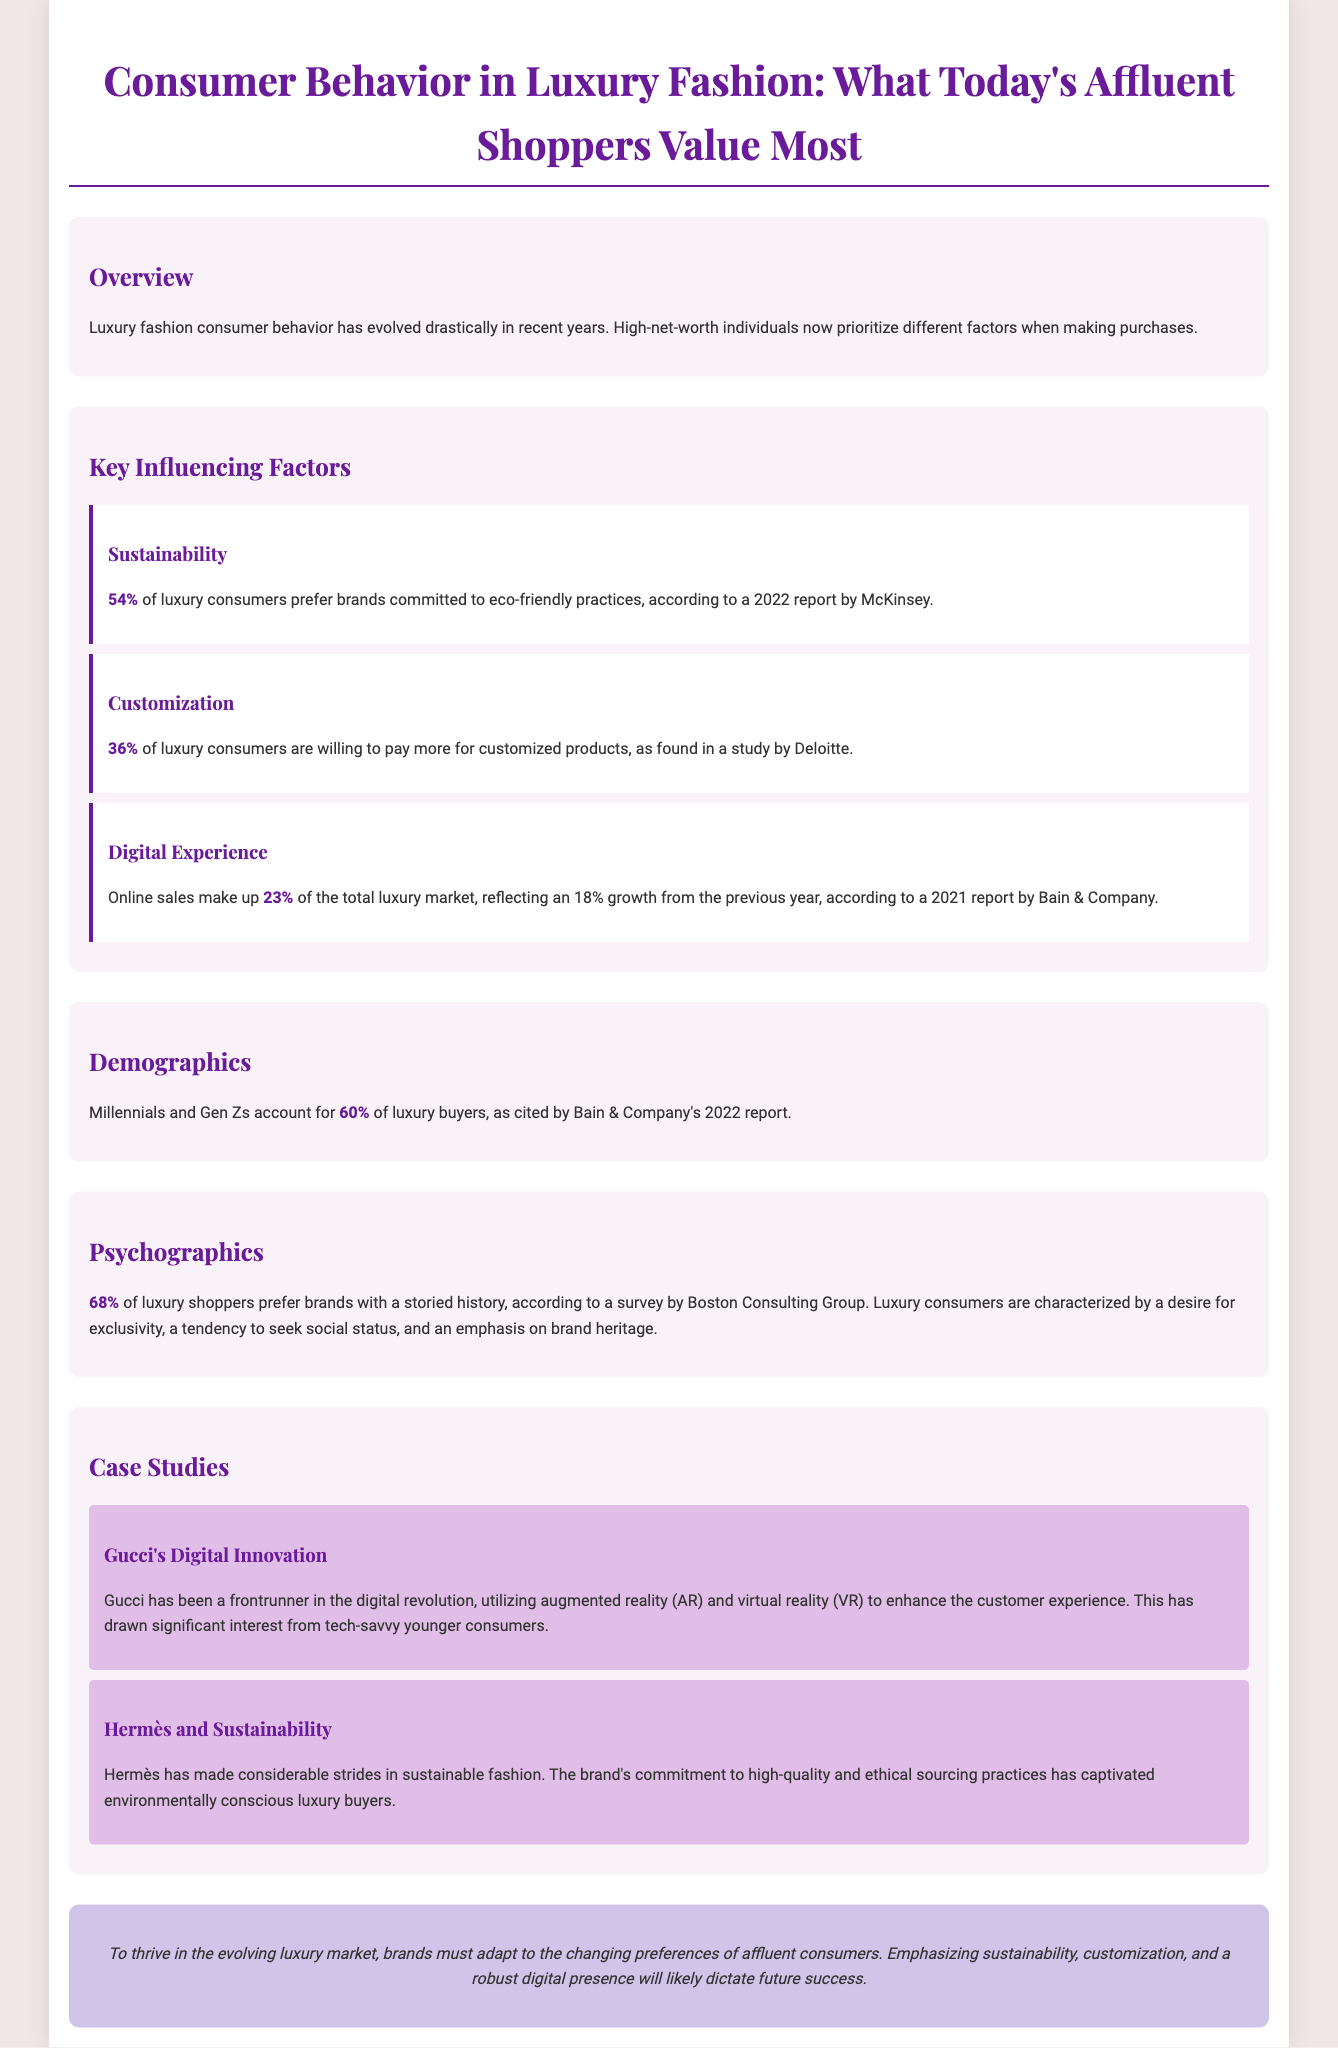What percentage of luxury consumers prefer sustainable brands? According to the McKinsey report, 54% of luxury consumers prefer brands committed to eco-friendly practices.
Answer: 54% What is the percentage of luxury consumers willing to pay more for customized products? A study by Deloitte found that 36% of luxury consumers are willing to pay more for customized products.
Answer: 36% What percentage of luxury buyers are Millennials and Gen Zs? Bain & Company's 2022 report cites that Millennials and Gen Zs account for 60% of luxury buyers.
Answer: 60% What growth percentage did online sales in luxury fashion experience from the previous year? The online sales in luxury fashion reflected an 18% growth from the previous year.
Answer: 18% Which luxury brand is highlighted for its commitment to sustainability? The infographic mentions Hermès for its considerable strides in sustainable fashion.
Answer: Hermès What is the primary characteristic luxury shoppers seek in brands? Luxury consumers are characterized by a desire for exclusivity.
Answer: Exclusivity What demographic accounts for a significant portion of luxury consumers? Millennials and Gen Zs represent a substantial segment of luxury consumers.
Answer: Millennials and Gen Zs Which digital innovations has Gucci utilized to enhance customer experience? Gucci has utilized augmented reality (AR) and virtual reality (VR) in its digital innovations.
Answer: Augmented reality and virtual reality 